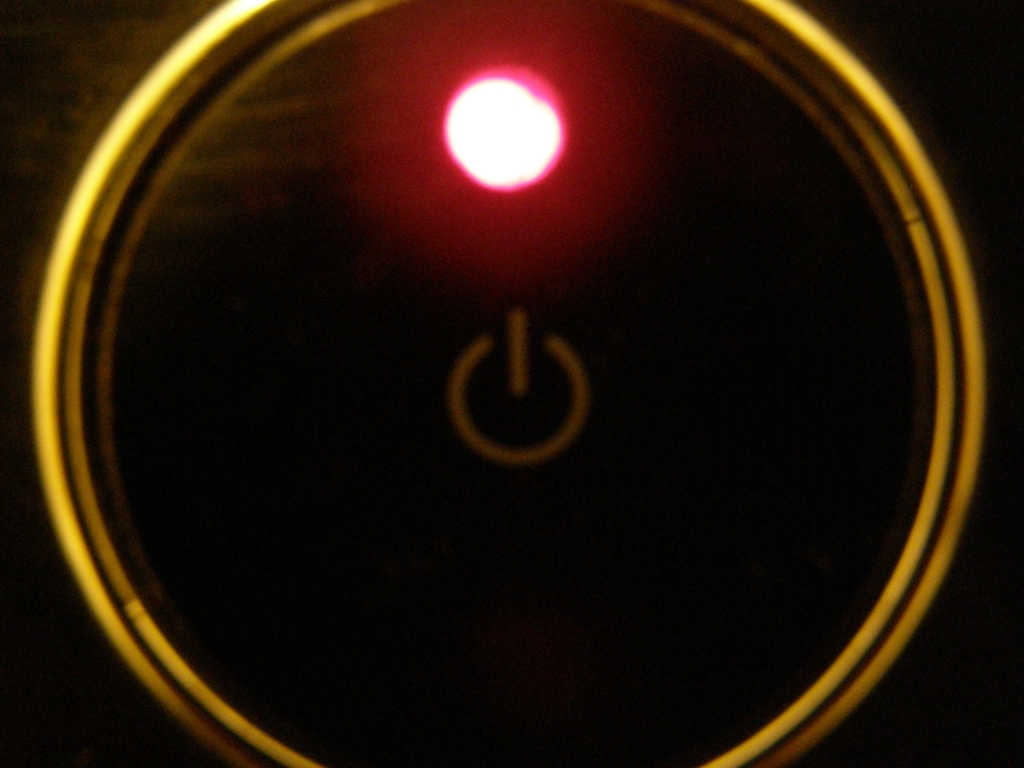Describe the atmosphere or mood conveyed by the image. The image portrays a mysterious and somewhat dramatic mood, highlighted by the stark contrast between the darkness that engulfs the scene and the singular, bright red light of the power button. The surrounding shadows deepen the sense of intrigue, as the solitary lit element invites curiosity about its purpose and the device it activates. 